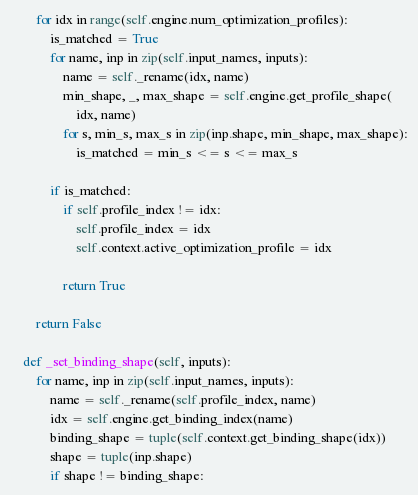<code> <loc_0><loc_0><loc_500><loc_500><_Python_>        for idx in range(self.engine.num_optimization_profiles):
            is_matched = True
            for name, inp in zip(self.input_names, inputs):
                name = self._rename(idx, name)
                min_shape, _, max_shape = self.engine.get_profile_shape(
                    idx, name)
                for s, min_s, max_s in zip(inp.shape, min_shape, max_shape):
                    is_matched = min_s <= s <= max_s

            if is_matched:
                if self.profile_index != idx:
                    self.profile_index = idx
                    self.context.active_optimization_profile = idx

                return True

        return False

    def _set_binding_shape(self, inputs):
        for name, inp in zip(self.input_names, inputs):
            name = self._rename(self.profile_index, name)
            idx = self.engine.get_binding_index(name)
            binding_shape = tuple(self.context.get_binding_shape(idx))
            shape = tuple(inp.shape)
            if shape != binding_shape:</code> 